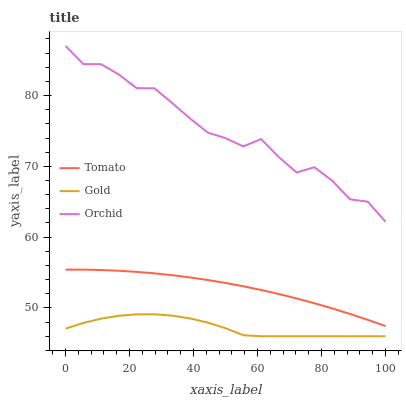Does Gold have the minimum area under the curve?
Answer yes or no. Yes. Does Orchid have the maximum area under the curve?
Answer yes or no. Yes. Does Orchid have the minimum area under the curve?
Answer yes or no. No. Does Gold have the maximum area under the curve?
Answer yes or no. No. Is Tomato the smoothest?
Answer yes or no. Yes. Is Orchid the roughest?
Answer yes or no. Yes. Is Gold the smoothest?
Answer yes or no. No. Is Gold the roughest?
Answer yes or no. No. Does Gold have the lowest value?
Answer yes or no. Yes. Does Orchid have the lowest value?
Answer yes or no. No. Does Orchid have the highest value?
Answer yes or no. Yes. Does Gold have the highest value?
Answer yes or no. No. Is Tomato less than Orchid?
Answer yes or no. Yes. Is Orchid greater than Gold?
Answer yes or no. Yes. Does Tomato intersect Orchid?
Answer yes or no. No. 